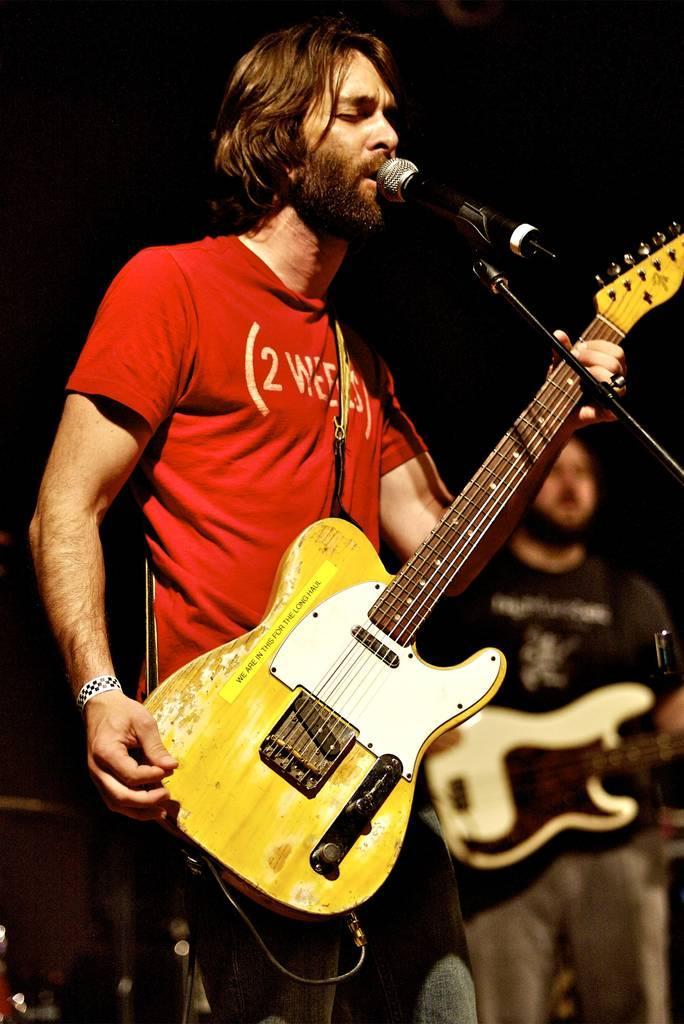How would you summarize this image in a sentence or two? In this image I can see a person with red T-shirt standing in-front of the mic and holding the guitar. In the back there is another person standing and holding guitar. 